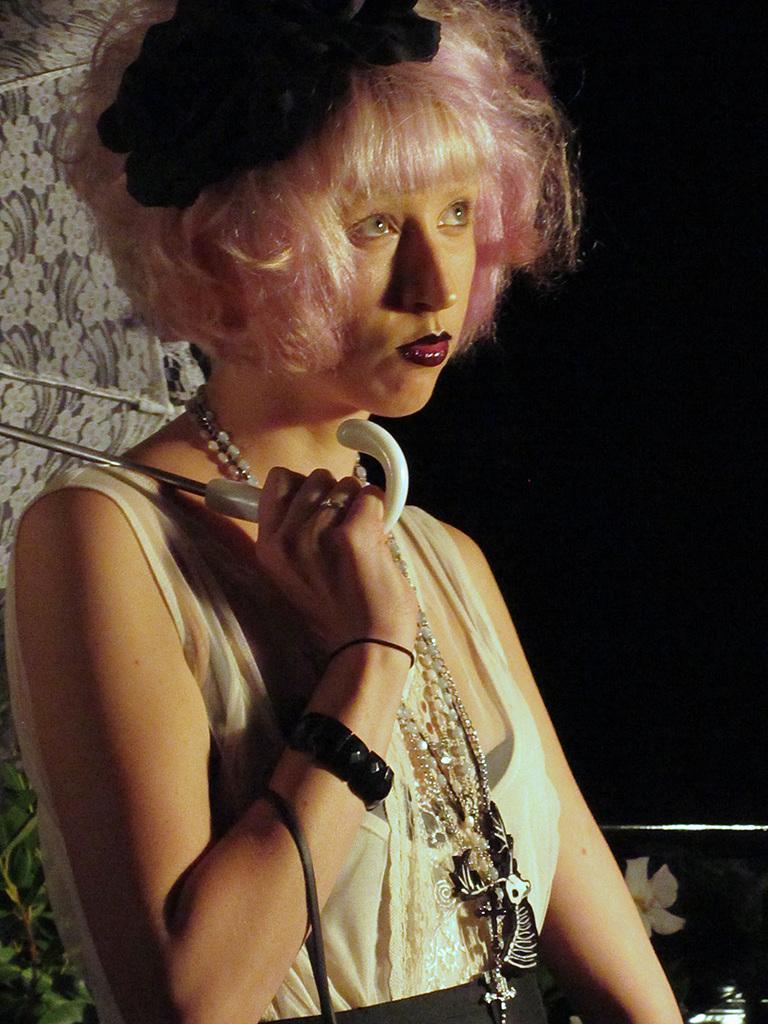Describe this image in one or two sentences. In this image in the foreground there is one woman who is wearing white dress, and she is holding an umbrella and she is wearing some ornaments. And there is a dark background and a lamp. 